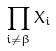Convert formula to latex. <formula><loc_0><loc_0><loc_500><loc_500>\prod _ { i \ne \beta } X _ { i }</formula> 